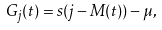Convert formula to latex. <formula><loc_0><loc_0><loc_500><loc_500>G _ { j } ( t ) = s ( j - M ( t ) ) - \mu ,</formula> 